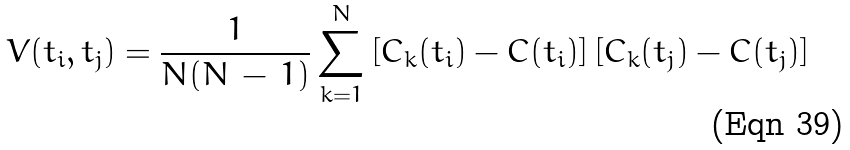Convert formula to latex. <formula><loc_0><loc_0><loc_500><loc_500>V ( t _ { i } , t _ { j } ) = \frac { 1 } { N ( N \, - \, 1 ) } \sum _ { k = 1 } ^ { N } \left [ C _ { k } ( t _ { i } ) - C ( t _ { i } ) \right ] \left [ C _ { k } ( t _ { j } ) - C ( t _ { j } ) \right ]</formula> 